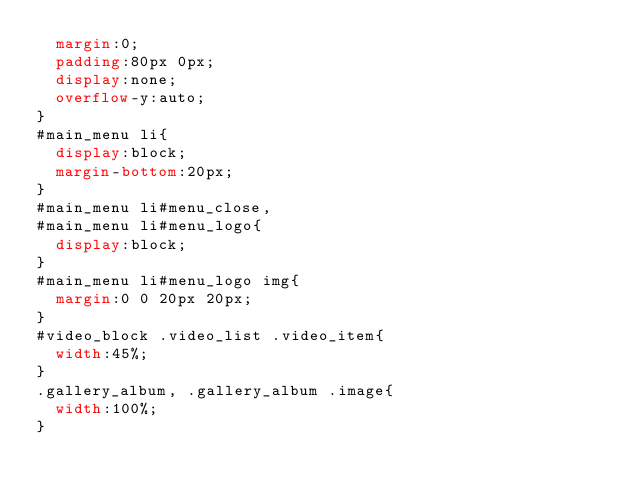<code> <loc_0><loc_0><loc_500><loc_500><_CSS_>	margin:0;
	padding:80px 0px;
	display:none;	
	overflow-y:auto;
}
#main_menu li{
	display:block;
	margin-bottom:20px;
}
#main_menu li#menu_close,
#main_menu li#menu_logo{
	display:block;
}
#main_menu li#menu_logo img{
	margin:0 0 20px 20px;
}
#video_block .video_list .video_item{
	width:45%;
}
.gallery_album, .gallery_album .image{
	width:100%;
}</code> 